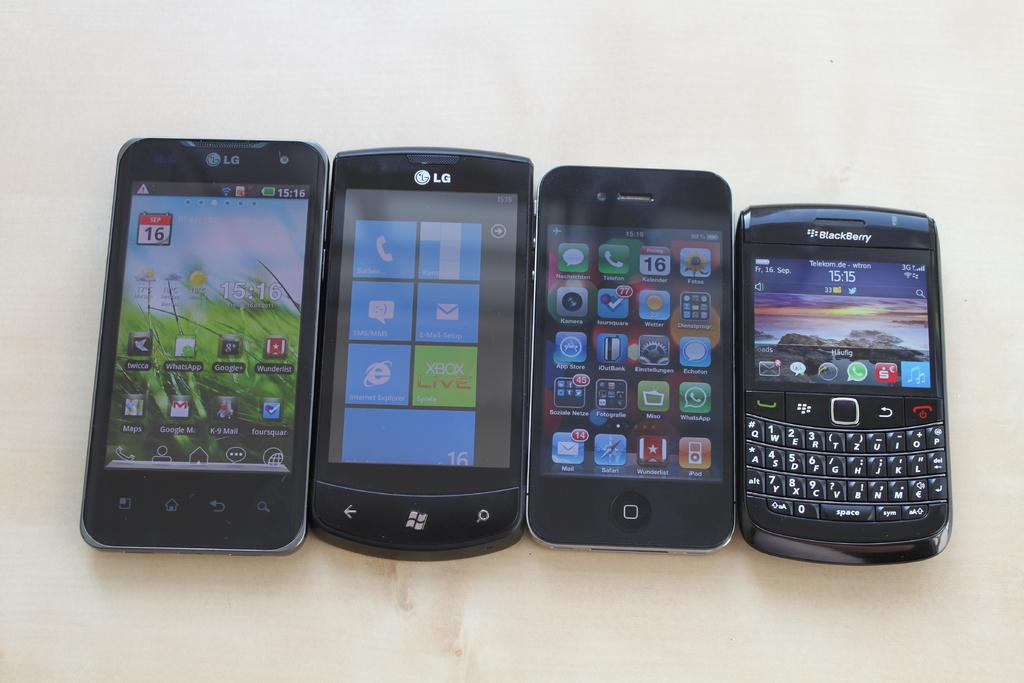How many mobile phones are visible in the image? There are four mobile phones in the image. Where are the mobile phones located? The mobile phones are on a table. How are the mobile phones arranged on the table? The mobile phones are arranged side by side. What type of haircut does the aftermath of the rate suggest in the image? There is no reference to a haircut, rate, or aftermath in the image, as it features four mobile phones arranged side by side on a table. 